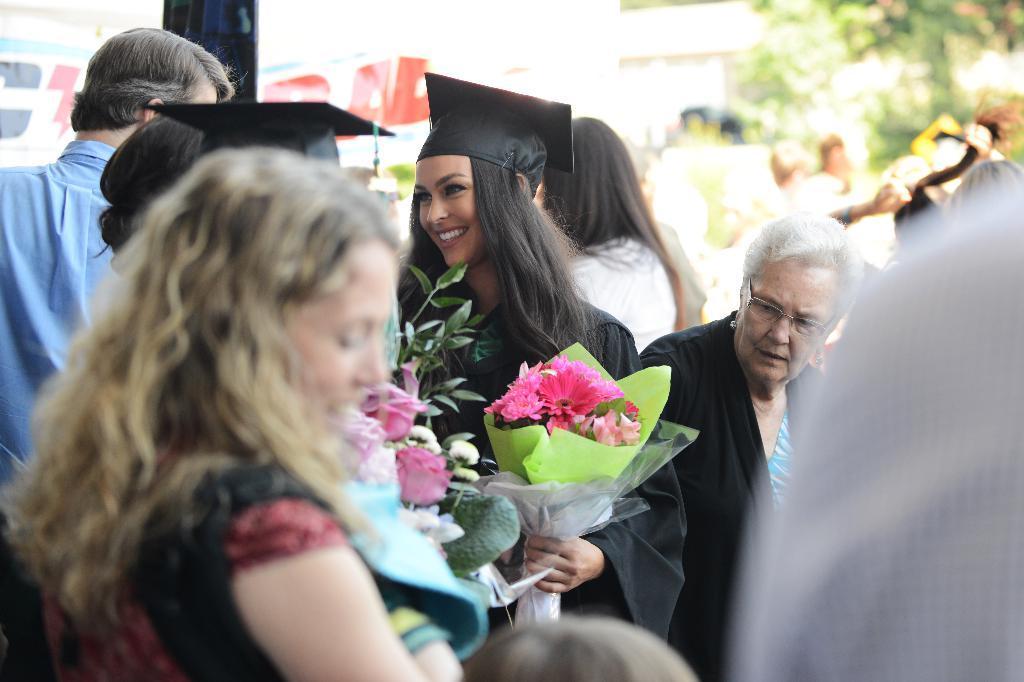Could you give a brief overview of what you see in this image? In this image I can see few people around. I can see a person is wearing black coat and black hat and holding a bouquet. I can see few colorful flowers. 